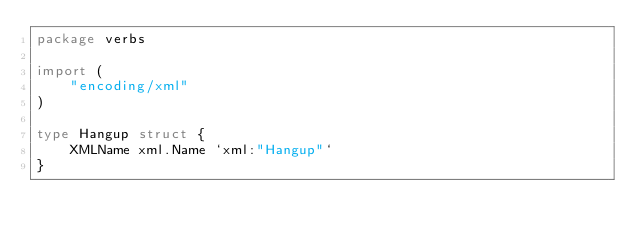Convert code to text. <code><loc_0><loc_0><loc_500><loc_500><_Go_>package verbs

import (
	"encoding/xml"
)

type Hangup struct {
	XMLName xml.Name `xml:"Hangup"`
}
</code> 